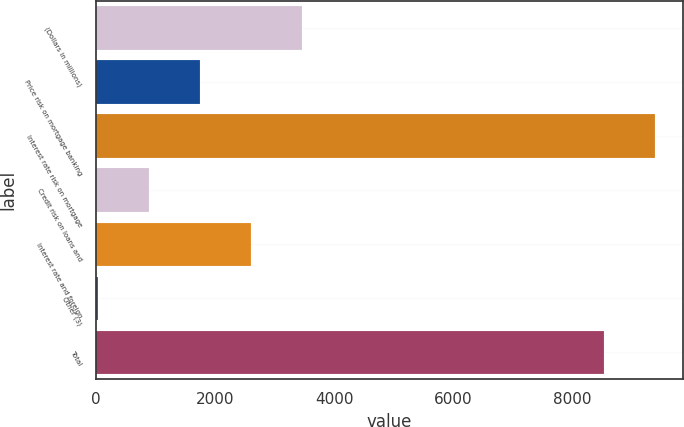Convert chart. <chart><loc_0><loc_0><loc_500><loc_500><bar_chart><fcel>(Dollars in millions)<fcel>Price risk on mortgage banking<fcel>Interest rate risk on mortgage<fcel>Credit risk on loans and<fcel>Interest rate and foreign<fcel>Other (3)<fcel>Total<nl><fcel>3464.4<fcel>1749.2<fcel>9386.6<fcel>891.6<fcel>2606.8<fcel>34<fcel>8529<nl></chart> 